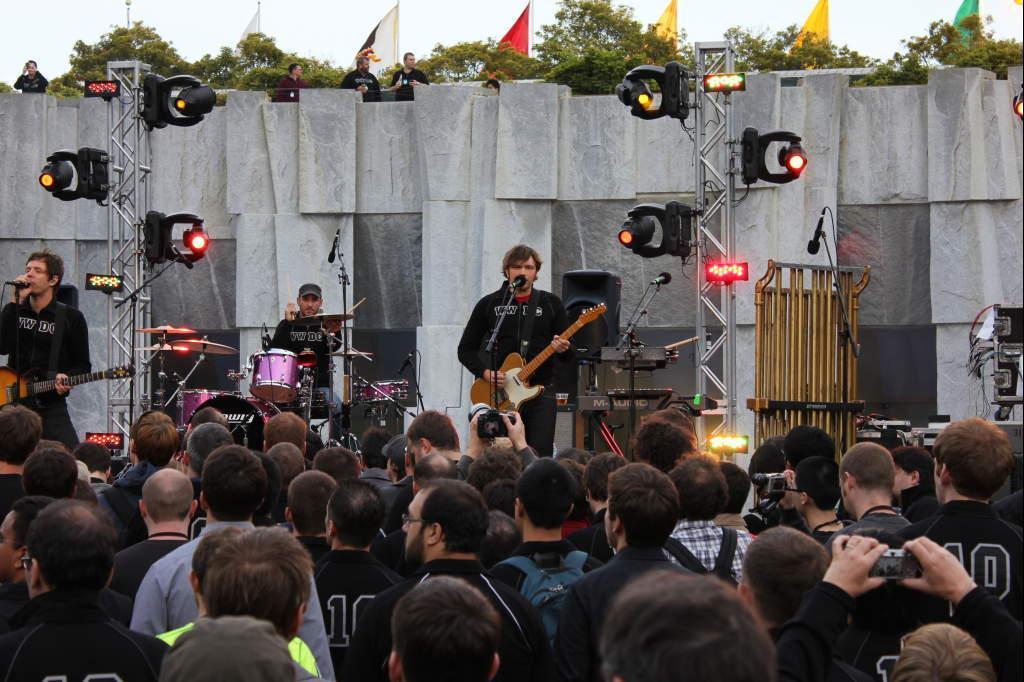Could you give a brief overview of what you see in this image? Here we can see a couple of people playing guitar and singing song with a microphone present in front of them and the person in the middle is playing drums with a microphone in front of him and there are colorful lights present and there are trees present and in front of them we can see people standing and listening to them and some people are recording their performance in video cameras 